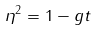Convert formula to latex. <formula><loc_0><loc_0><loc_500><loc_500>\eta ^ { 2 } = 1 - g t</formula> 